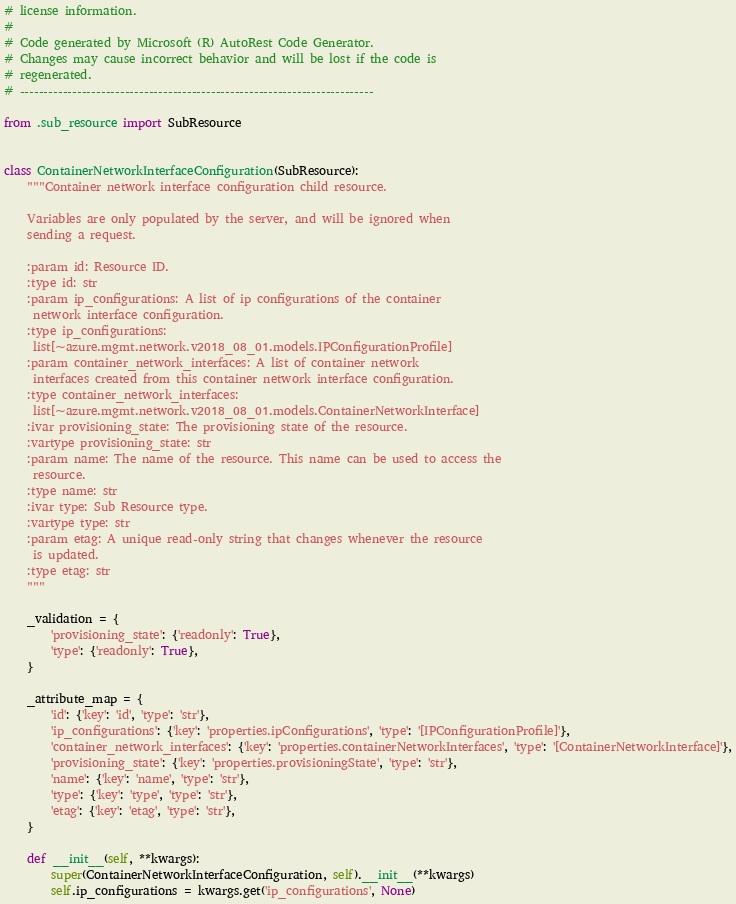<code> <loc_0><loc_0><loc_500><loc_500><_Python_># license information.
#
# Code generated by Microsoft (R) AutoRest Code Generator.
# Changes may cause incorrect behavior and will be lost if the code is
# regenerated.
# --------------------------------------------------------------------------

from .sub_resource import SubResource


class ContainerNetworkInterfaceConfiguration(SubResource):
    """Container network interface configuration child resource.

    Variables are only populated by the server, and will be ignored when
    sending a request.

    :param id: Resource ID.
    :type id: str
    :param ip_configurations: A list of ip configurations of the container
     network interface configuration.
    :type ip_configurations:
     list[~azure.mgmt.network.v2018_08_01.models.IPConfigurationProfile]
    :param container_network_interfaces: A list of container network
     interfaces created from this container network interface configuration.
    :type container_network_interfaces:
     list[~azure.mgmt.network.v2018_08_01.models.ContainerNetworkInterface]
    :ivar provisioning_state: The provisioning state of the resource.
    :vartype provisioning_state: str
    :param name: The name of the resource. This name can be used to access the
     resource.
    :type name: str
    :ivar type: Sub Resource type.
    :vartype type: str
    :param etag: A unique read-only string that changes whenever the resource
     is updated.
    :type etag: str
    """

    _validation = {
        'provisioning_state': {'readonly': True},
        'type': {'readonly': True},
    }

    _attribute_map = {
        'id': {'key': 'id', 'type': 'str'},
        'ip_configurations': {'key': 'properties.ipConfigurations', 'type': '[IPConfigurationProfile]'},
        'container_network_interfaces': {'key': 'properties.containerNetworkInterfaces', 'type': '[ContainerNetworkInterface]'},
        'provisioning_state': {'key': 'properties.provisioningState', 'type': 'str'},
        'name': {'key': 'name', 'type': 'str'},
        'type': {'key': 'type', 'type': 'str'},
        'etag': {'key': 'etag', 'type': 'str'},
    }

    def __init__(self, **kwargs):
        super(ContainerNetworkInterfaceConfiguration, self).__init__(**kwargs)
        self.ip_configurations = kwargs.get('ip_configurations', None)</code> 